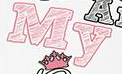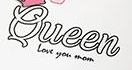What text appears in these images from left to right, separated by a semicolon? My; Queen 